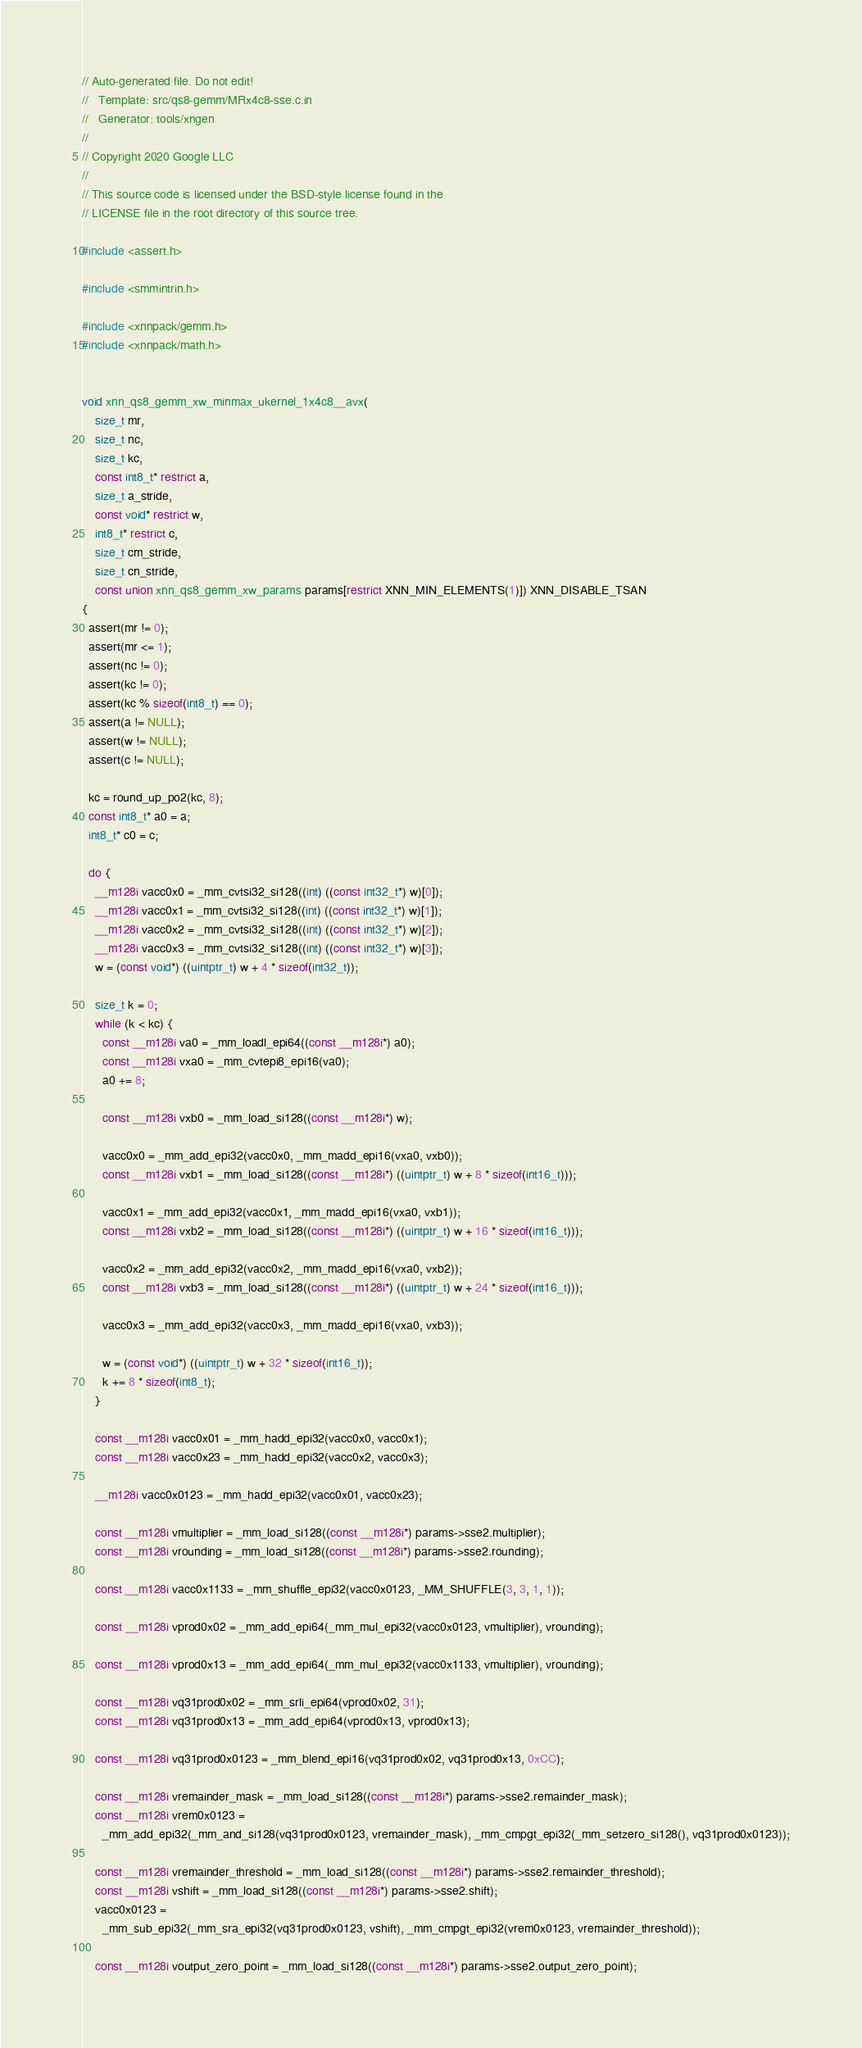<code> <loc_0><loc_0><loc_500><loc_500><_C_>// Auto-generated file. Do not edit!
//   Template: src/qs8-gemm/MRx4c8-sse.c.in
//   Generator: tools/xngen
//
// Copyright 2020 Google LLC
//
// This source code is licensed under the BSD-style license found in the
// LICENSE file in the root directory of this source tree.

#include <assert.h>

#include <smmintrin.h>

#include <xnnpack/gemm.h>
#include <xnnpack/math.h>


void xnn_qs8_gemm_xw_minmax_ukernel_1x4c8__avx(
    size_t mr,
    size_t nc,
    size_t kc,
    const int8_t* restrict a,
    size_t a_stride,
    const void* restrict w,
    int8_t* restrict c,
    size_t cm_stride,
    size_t cn_stride,
    const union xnn_qs8_gemm_xw_params params[restrict XNN_MIN_ELEMENTS(1)]) XNN_DISABLE_TSAN
{
  assert(mr != 0);
  assert(mr <= 1);
  assert(nc != 0);
  assert(kc != 0);
  assert(kc % sizeof(int8_t) == 0);
  assert(a != NULL);
  assert(w != NULL);
  assert(c != NULL);

  kc = round_up_po2(kc, 8);
  const int8_t* a0 = a;
  int8_t* c0 = c;

  do {
    __m128i vacc0x0 = _mm_cvtsi32_si128((int) ((const int32_t*) w)[0]);
    __m128i vacc0x1 = _mm_cvtsi32_si128((int) ((const int32_t*) w)[1]);
    __m128i vacc0x2 = _mm_cvtsi32_si128((int) ((const int32_t*) w)[2]);
    __m128i vacc0x3 = _mm_cvtsi32_si128((int) ((const int32_t*) w)[3]);
    w = (const void*) ((uintptr_t) w + 4 * sizeof(int32_t));

    size_t k = 0;
    while (k < kc) {
      const __m128i va0 = _mm_loadl_epi64((const __m128i*) a0);
      const __m128i vxa0 = _mm_cvtepi8_epi16(va0);
      a0 += 8;

      const __m128i vxb0 = _mm_load_si128((const __m128i*) w);

      vacc0x0 = _mm_add_epi32(vacc0x0, _mm_madd_epi16(vxa0, vxb0));
      const __m128i vxb1 = _mm_load_si128((const __m128i*) ((uintptr_t) w + 8 * sizeof(int16_t)));

      vacc0x1 = _mm_add_epi32(vacc0x1, _mm_madd_epi16(vxa0, vxb1));
      const __m128i vxb2 = _mm_load_si128((const __m128i*) ((uintptr_t) w + 16 * sizeof(int16_t)));

      vacc0x2 = _mm_add_epi32(vacc0x2, _mm_madd_epi16(vxa0, vxb2));
      const __m128i vxb3 = _mm_load_si128((const __m128i*) ((uintptr_t) w + 24 * sizeof(int16_t)));

      vacc0x3 = _mm_add_epi32(vacc0x3, _mm_madd_epi16(vxa0, vxb3));

      w = (const void*) ((uintptr_t) w + 32 * sizeof(int16_t));
      k += 8 * sizeof(int8_t);
    }

    const __m128i vacc0x01 = _mm_hadd_epi32(vacc0x0, vacc0x1);
    const __m128i vacc0x23 = _mm_hadd_epi32(vacc0x2, vacc0x3);

    __m128i vacc0x0123 = _mm_hadd_epi32(vacc0x01, vacc0x23);

    const __m128i vmultiplier = _mm_load_si128((const __m128i*) params->sse2.multiplier);
    const __m128i vrounding = _mm_load_si128((const __m128i*) params->sse2.rounding);

    const __m128i vacc0x1133 = _mm_shuffle_epi32(vacc0x0123, _MM_SHUFFLE(3, 3, 1, 1));

    const __m128i vprod0x02 = _mm_add_epi64(_mm_mul_epi32(vacc0x0123, vmultiplier), vrounding);

    const __m128i vprod0x13 = _mm_add_epi64(_mm_mul_epi32(vacc0x1133, vmultiplier), vrounding);

    const __m128i vq31prod0x02 = _mm_srli_epi64(vprod0x02, 31);
    const __m128i vq31prod0x13 = _mm_add_epi64(vprod0x13, vprod0x13);

    const __m128i vq31prod0x0123 = _mm_blend_epi16(vq31prod0x02, vq31prod0x13, 0xCC);

    const __m128i vremainder_mask = _mm_load_si128((const __m128i*) params->sse2.remainder_mask);
    const __m128i vrem0x0123 =
      _mm_add_epi32(_mm_and_si128(vq31prod0x0123, vremainder_mask), _mm_cmpgt_epi32(_mm_setzero_si128(), vq31prod0x0123));

    const __m128i vremainder_threshold = _mm_load_si128((const __m128i*) params->sse2.remainder_threshold);
    const __m128i vshift = _mm_load_si128((const __m128i*) params->sse2.shift);
    vacc0x0123 =
      _mm_sub_epi32(_mm_sra_epi32(vq31prod0x0123, vshift), _mm_cmpgt_epi32(vrem0x0123, vremainder_threshold));

    const __m128i voutput_zero_point = _mm_load_si128((const __m128i*) params->sse2.output_zero_point);</code> 